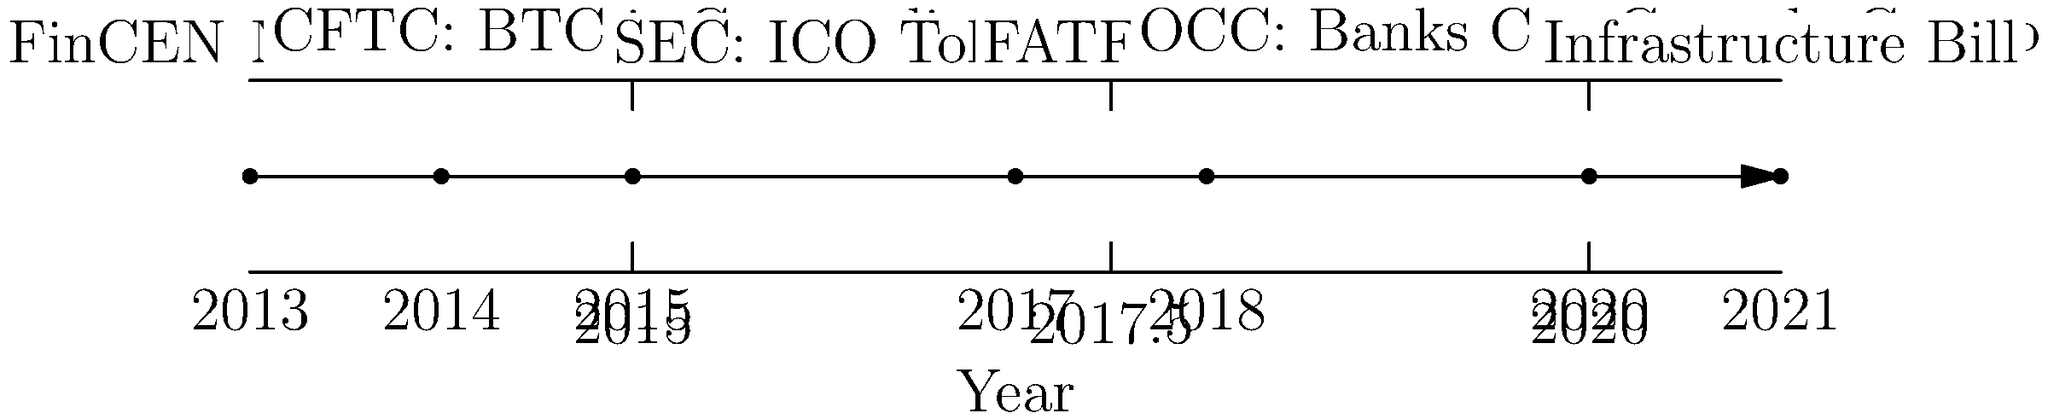Based on the timeline of cryptocurrency regulatory milestones shown, which event marked a significant shift in how Initial Coin Offerings (ICOs) were perceived by U.S. regulators, and what was the key implication of this ruling? To answer this question, we need to analyze the timeline and identify the event related to ICOs:

1. Scan the timeline for ICO-related events.
2. The relevant event is in 2017: "SEC: ICO Tokens = Securities"
3. This event signifies that the U.S. Securities and Exchange Commission (SEC) classified ICO tokens as securities.
4. The key implication of this ruling:
   a) ICOs would now be subject to federal securities laws.
   b) Companies conducting ICOs would need to register with the SEC or qualify for an exemption.
   c) This increased regulatory scrutiny and compliance requirements for cryptocurrency projects raising funds through ICOs.
   d) It effectively brought ICOs under the same regulatory framework as traditional securities offerings.

5. This ruling marked a significant shift because:
   a) Previously, ICOs operated in a regulatory grey area.
   b) It clarified the SEC's stance on token sales and cryptocurrency fundraising.
   c) It set a precedent for how digital assets would be treated under U.S. securities law.
Answer: 2017 SEC ruling classifying ICO tokens as securities, subjecting them to federal securities laws. 